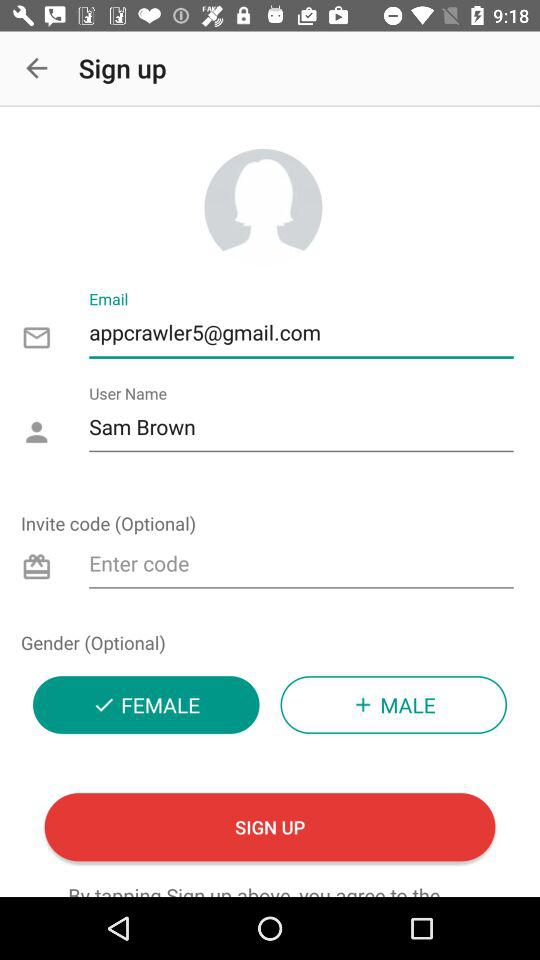How many gender options are there?
Answer the question using a single word or phrase. 2 